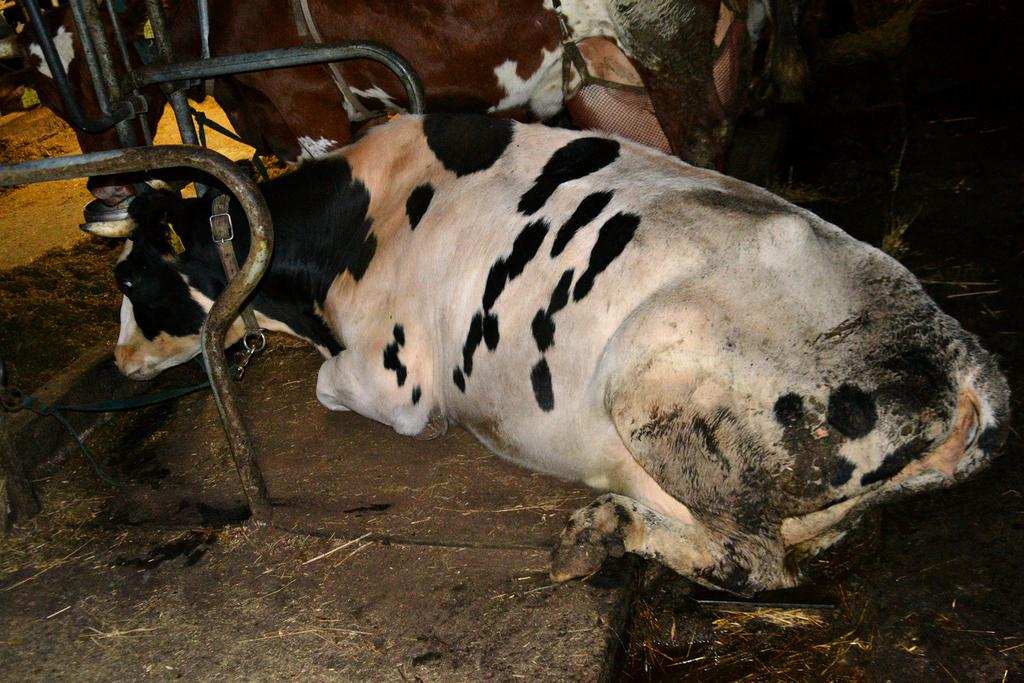How many animals are present in the image? There are two animals in the image. What are the animals wearing? The animals are wearing belts. What can be seen in the image besides the animals? There are poles and grass on the ground in the image. What is the color of the background in the image? The background of the image is dark. What type of pin can be seen holding the animals' costumes together in the image? There is no pin visible in the image; the animals are wearing belts. What nation is being represented by the animals in the image? The image does not depict any specific nation or national symbols. 